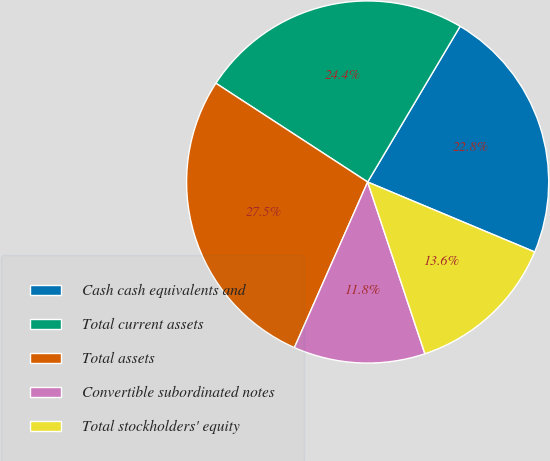Convert chart to OTSL. <chart><loc_0><loc_0><loc_500><loc_500><pie_chart><fcel>Cash cash equivalents and<fcel>Total current assets<fcel>Total assets<fcel>Convertible subordinated notes<fcel>Total stockholders' equity<nl><fcel>22.78%<fcel>24.35%<fcel>27.55%<fcel>11.75%<fcel>13.57%<nl></chart> 